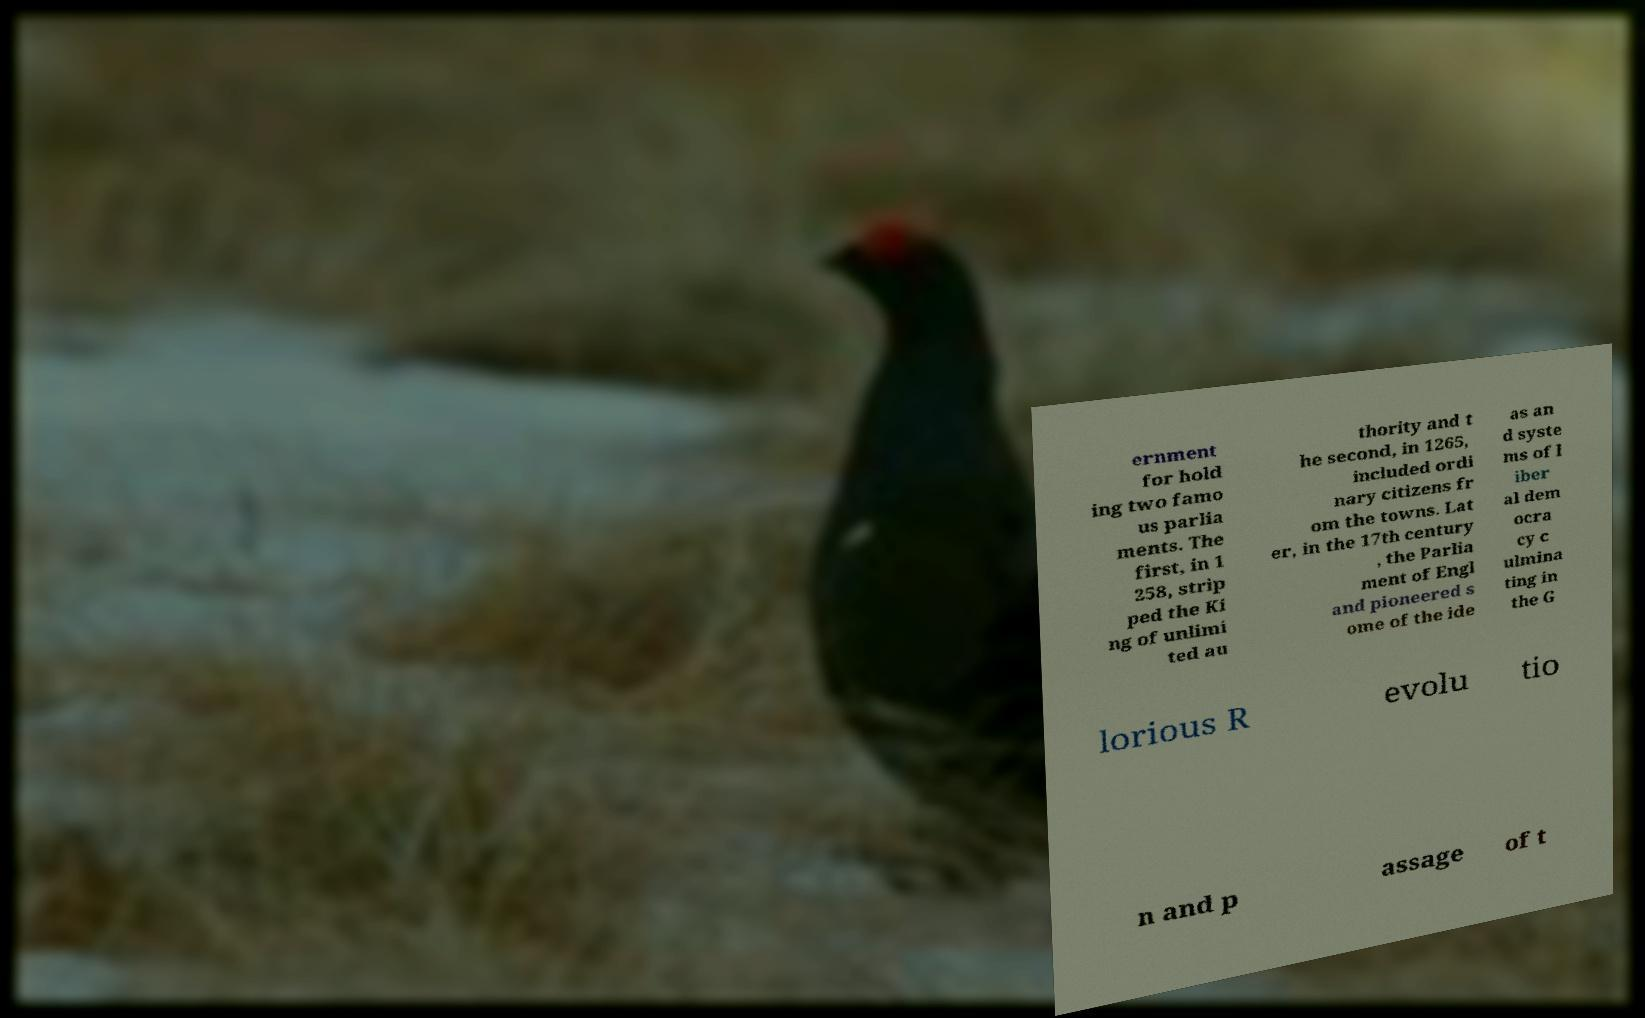Please read and relay the text visible in this image. What does it say? ernment for hold ing two famo us parlia ments. The first, in 1 258, strip ped the Ki ng of unlimi ted au thority and t he second, in 1265, included ordi nary citizens fr om the towns. Lat er, in the 17th century , the Parlia ment of Engl and pioneered s ome of the ide as an d syste ms of l iber al dem ocra cy c ulmina ting in the G lorious R evolu tio n and p assage of t 